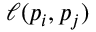Convert formula to latex. <formula><loc_0><loc_0><loc_500><loc_500>\ell ( p _ { i } , p _ { j } )</formula> 